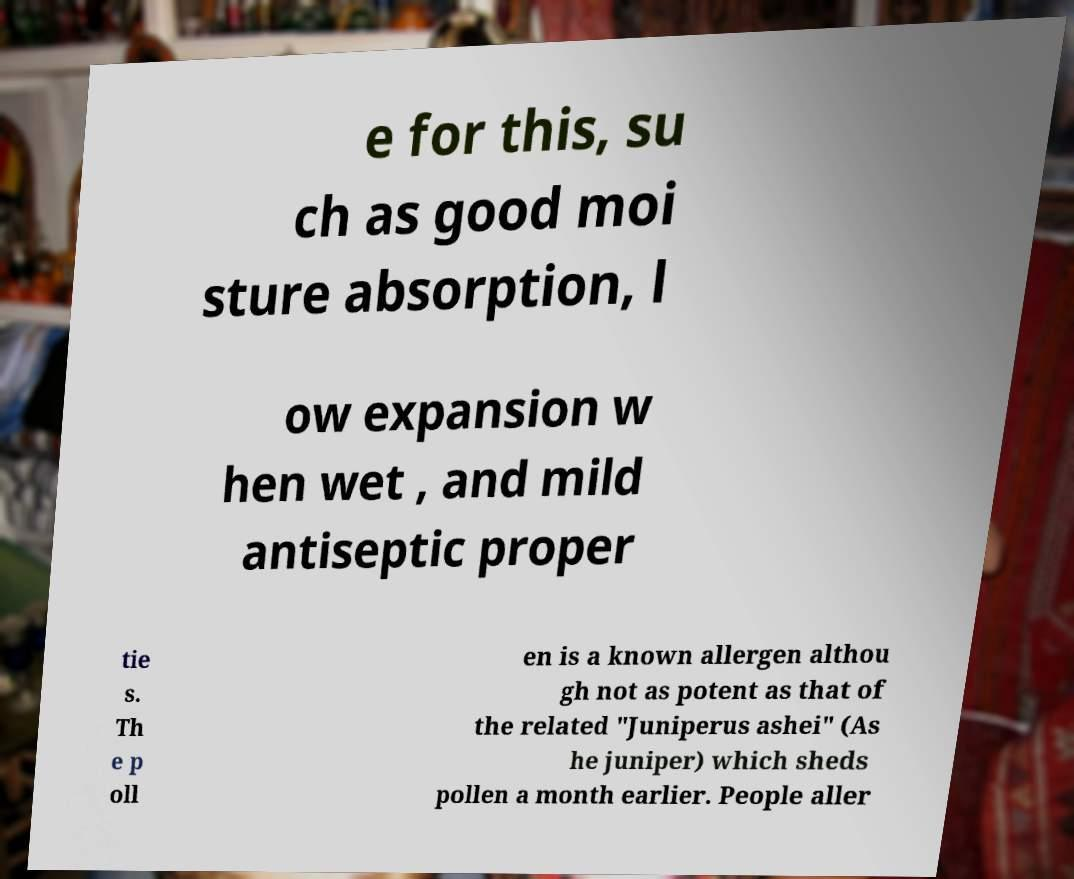Can you read and provide the text displayed in the image?This photo seems to have some interesting text. Can you extract and type it out for me? e for this, su ch as good moi sture absorption, l ow expansion w hen wet , and mild antiseptic proper tie s. Th e p oll en is a known allergen althou gh not as potent as that of the related "Juniperus ashei" (As he juniper) which sheds pollen a month earlier. People aller 